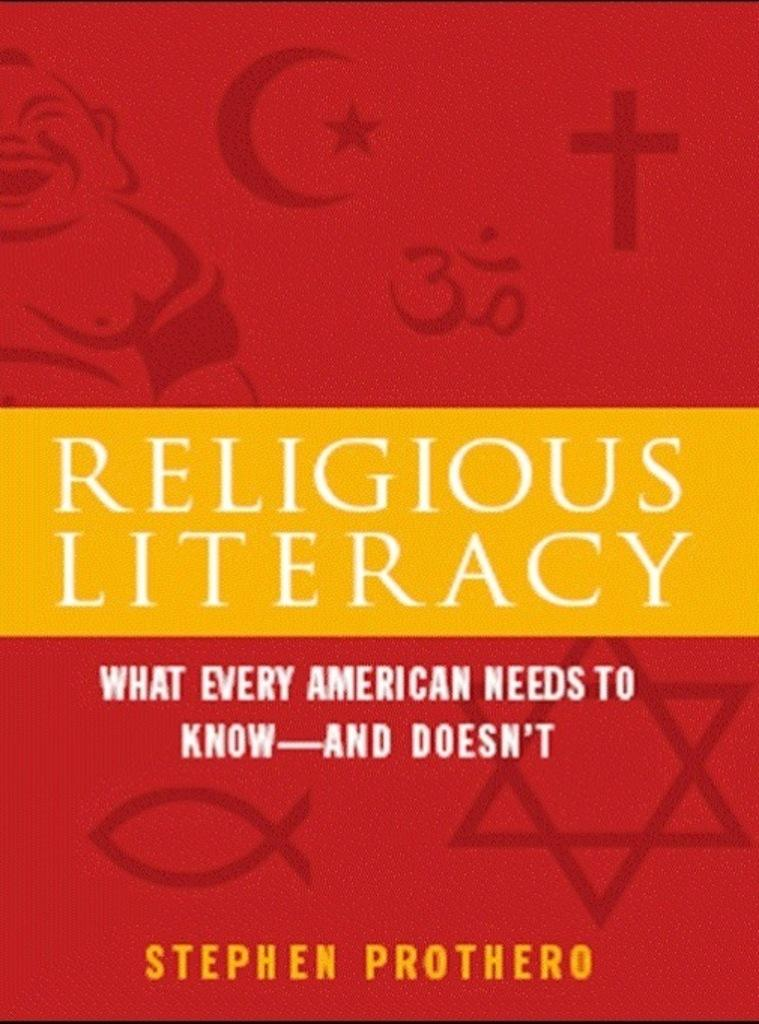<image>
Create a compact narrative representing the image presented. A book on Religious Literacy what every American needs to know and doesn't written by Stephen Prothero. 